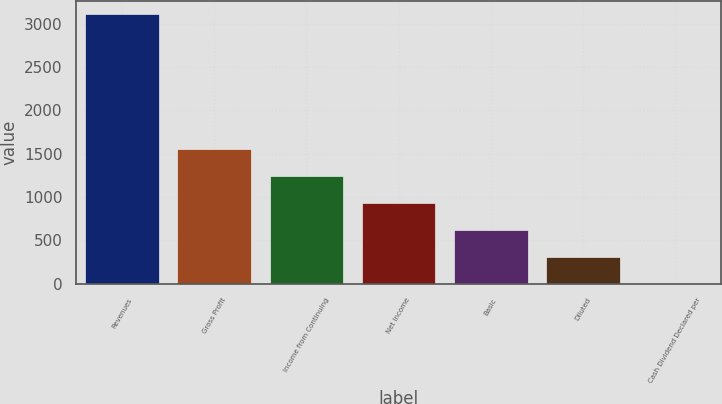Convert chart to OTSL. <chart><loc_0><loc_0><loc_500><loc_500><bar_chart><fcel>Revenues<fcel>Gross Profit<fcel>Income from Continuing<fcel>Net Income<fcel>Basic<fcel>Diluted<fcel>Cash Dividend Declared per<nl><fcel>3108.1<fcel>1554.13<fcel>1243.33<fcel>932.53<fcel>621.73<fcel>310.93<fcel>0.13<nl></chart> 